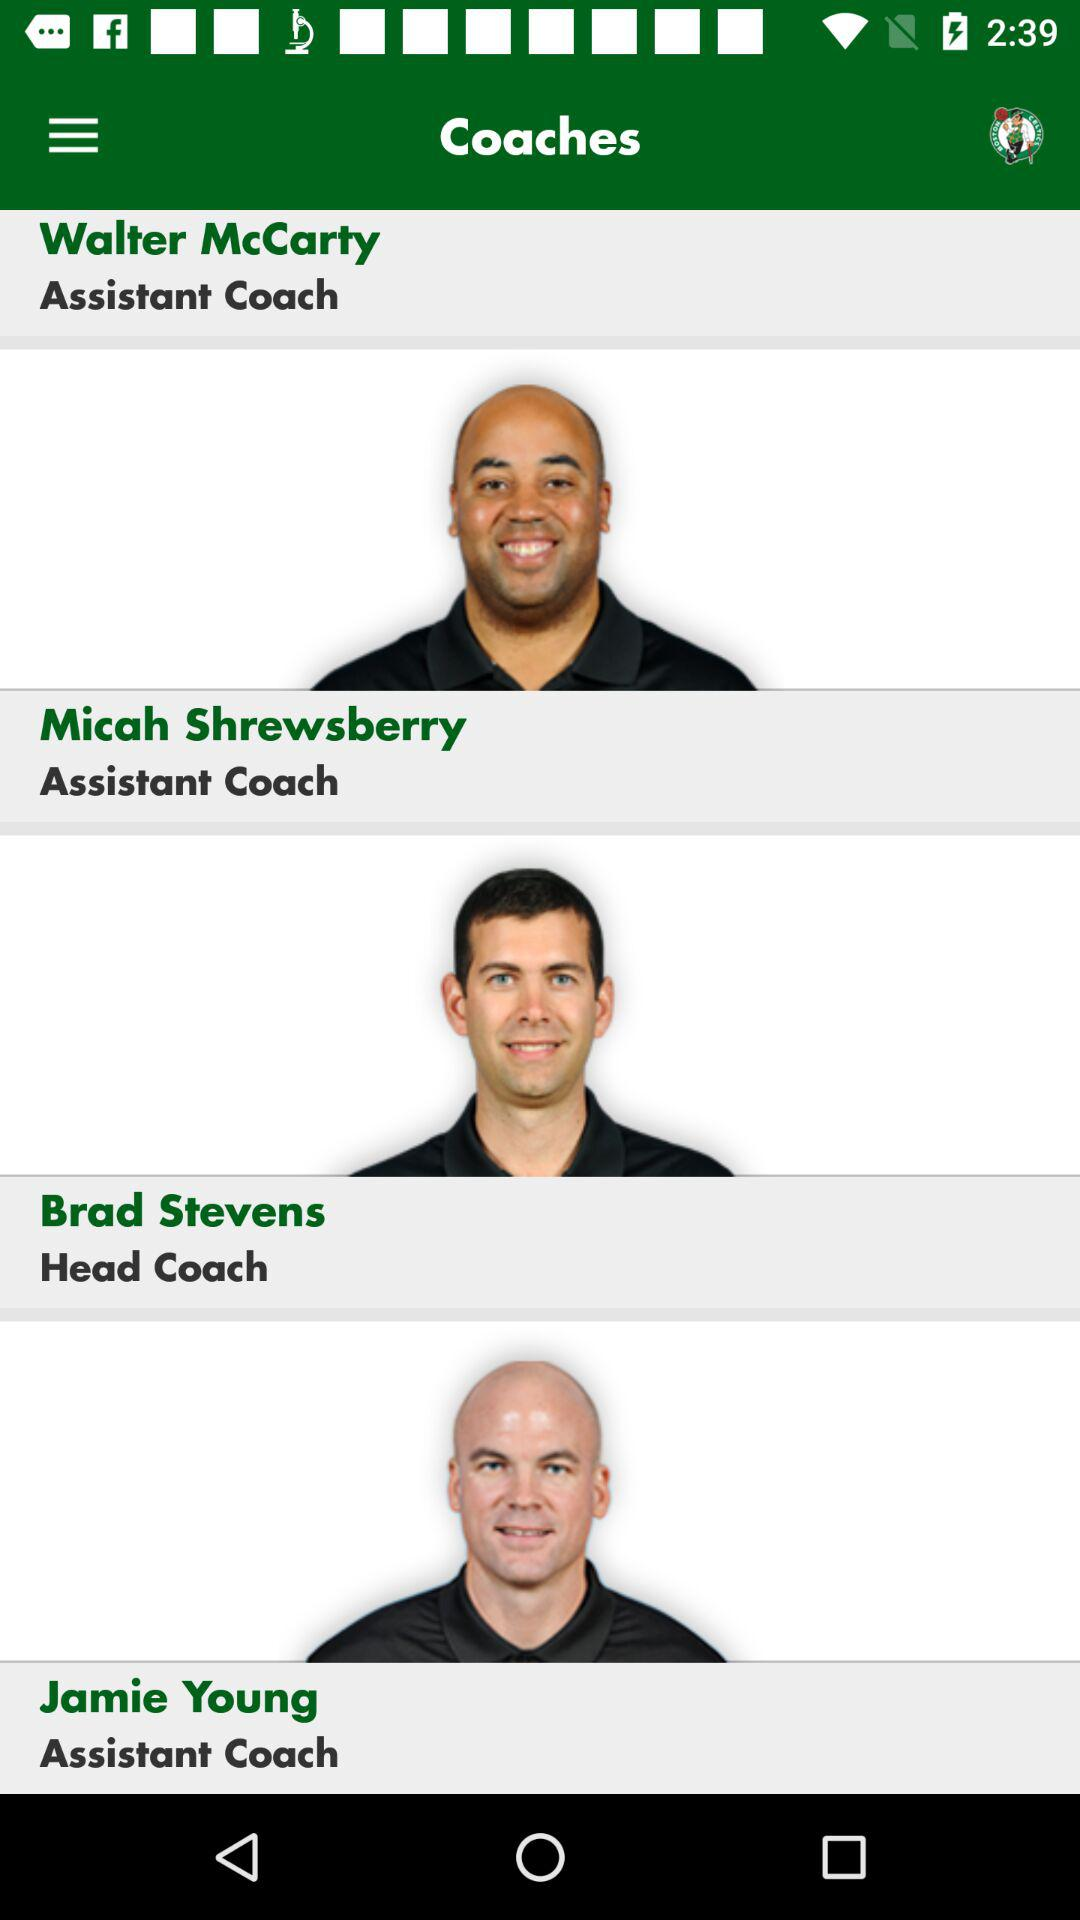What is the designation of Micah Shrewsberry? The designation of Micah Shrewsberry is "Assistant Coach". 